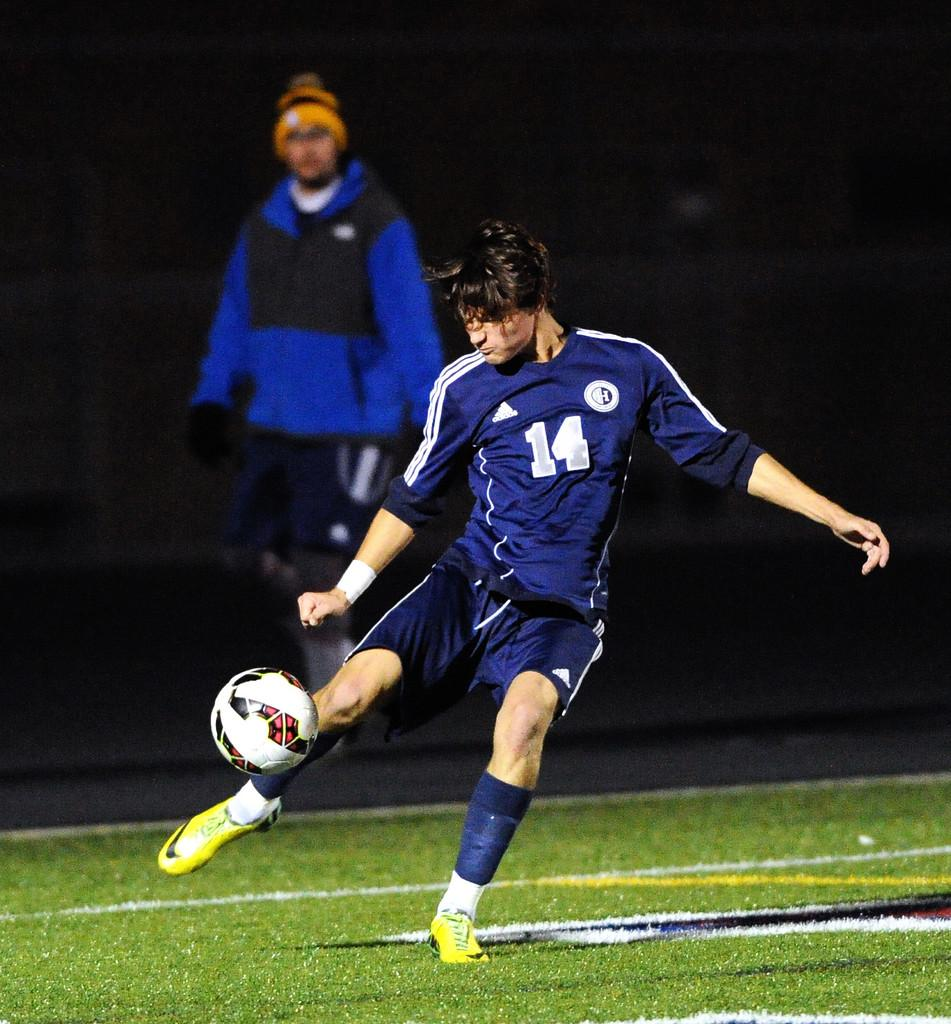<image>
Render a clear and concise summary of the photo. a football player in yellow boots kicking a ball with a number 14 on his shirt 